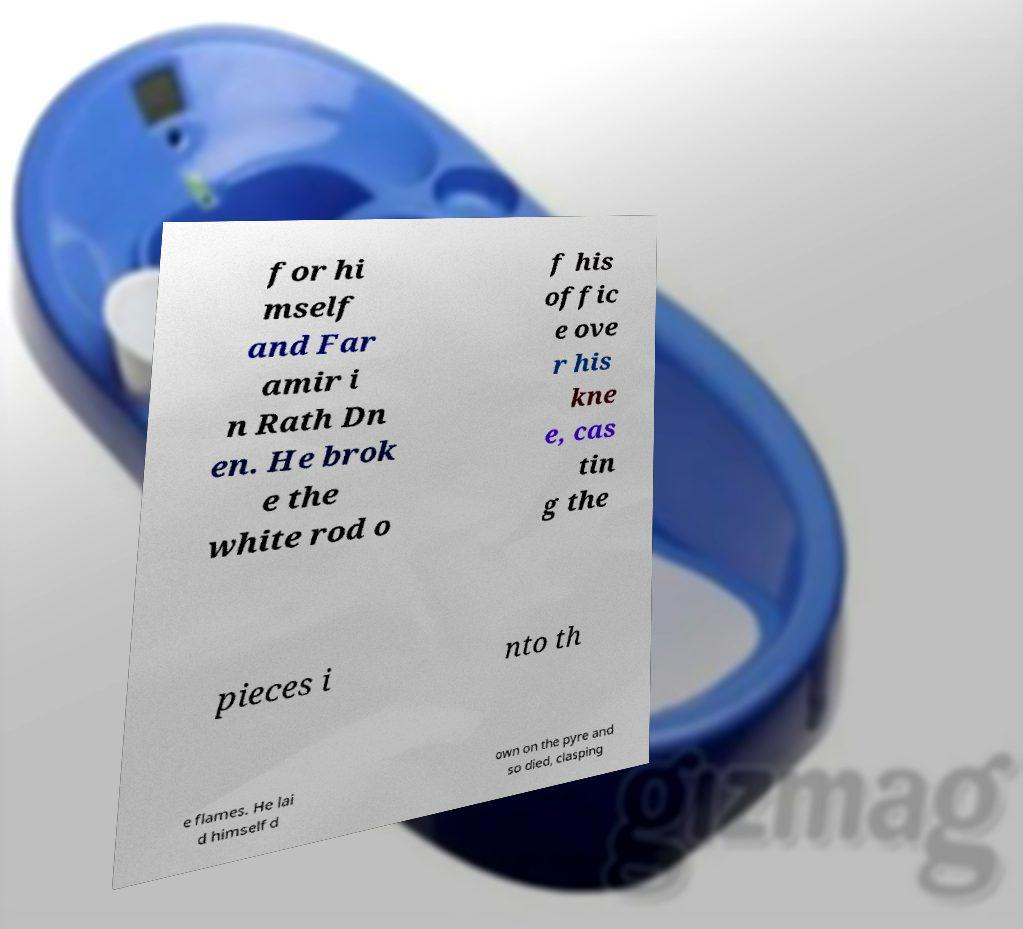Can you accurately transcribe the text from the provided image for me? for hi mself and Far amir i n Rath Dn en. He brok e the white rod o f his offic e ove r his kne e, cas tin g the pieces i nto th e flames. He lai d himself d own on the pyre and so died, clasping 